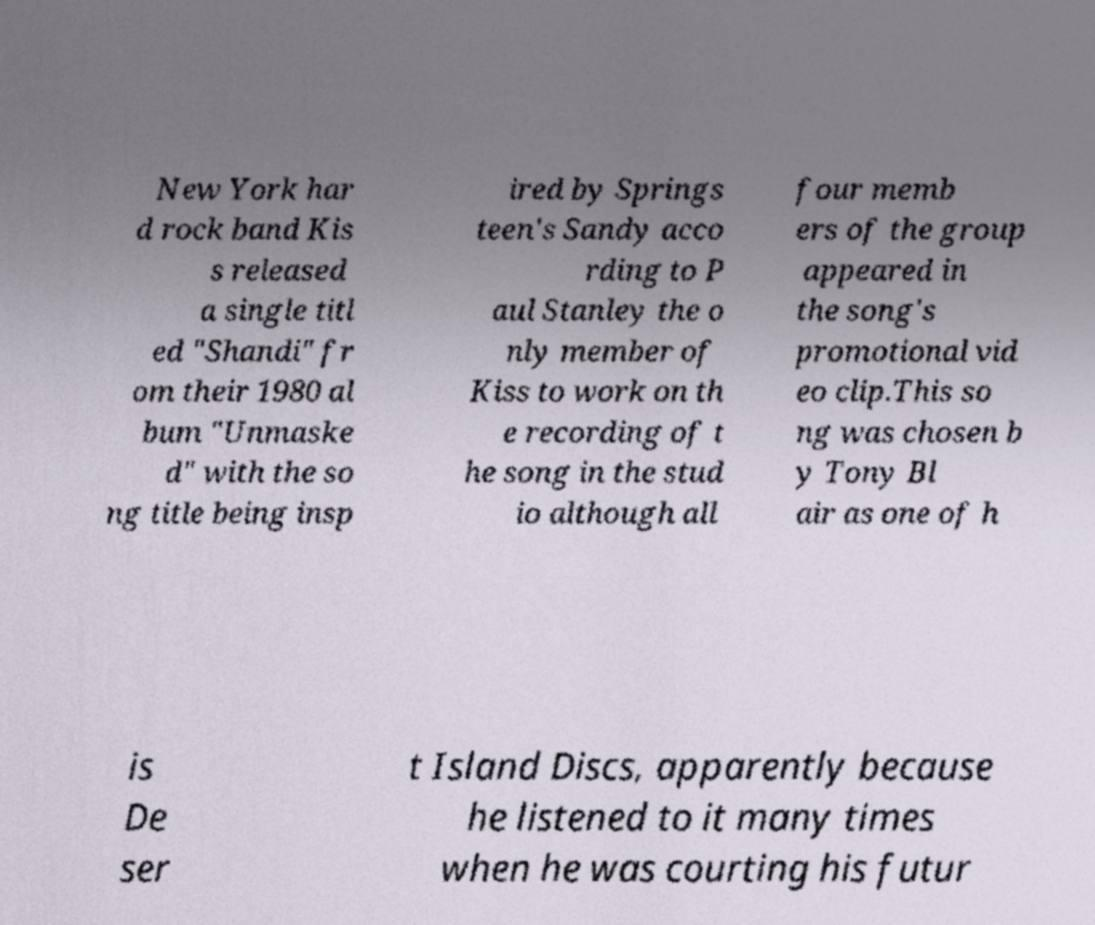Could you extract and type out the text from this image? New York har d rock band Kis s released a single titl ed "Shandi" fr om their 1980 al bum "Unmaske d" with the so ng title being insp ired by Springs teen's Sandy acco rding to P aul Stanley the o nly member of Kiss to work on th e recording of t he song in the stud io although all four memb ers of the group appeared in the song's promotional vid eo clip.This so ng was chosen b y Tony Bl air as one of h is De ser t Island Discs, apparently because he listened to it many times when he was courting his futur 